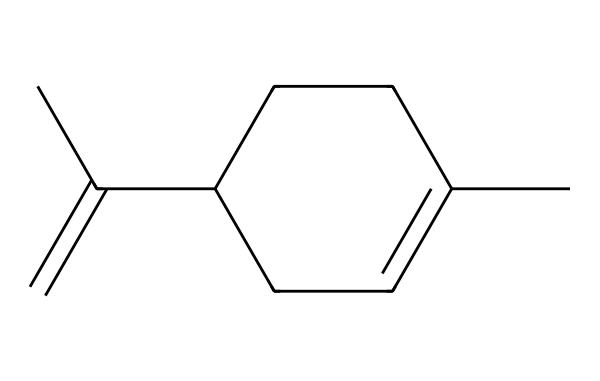What is the molecular formula of limonene? To determine the molecular formula, we can count the number of carbon (C) and hydrogen (H) atoms in the structure based on the SMILES representation. There are 10 carbon atoms and 16 hydrogen atoms present in the structure.
Answer: C10H16 How many rings are present in the structure? By analyzing the SMILES notation, we can observe the presence of a ring indicated by 'C1=...' and 'CC1' which shows that there is one ring in the structure.
Answer: 1 What type of bond connects the carbon atoms in the ring? The presence of '=' in the SMILES indicates a double bond between carbon atoms in the ring. This can be seen in the portion 'CC1=CCC', confirming the existence of double bonds in the cyclic structure.
Answer: double bond Is limonene an aromatic compound? Limonene does not contain a fully conjugated pi electron system nor a benzene-like ring that would classify it as aromatic. Even though it has a cyclic structure, it lacks the specific characteristics of aromaticity.
Answer: no What characteristic scent is limonene responsible for? Limonene is primarily recognized for emitting a citrus scent, which is attributed to the arrangement of its molecular structure, notably as it relates to its carbon framework and functional groups.
Answer: citrus scent Which is the major functional group in limonene? Analyzing the structure, limonene primarily features a double bond between carbon atoms, typical of alkenes rather than a distinct functional group like alcohol or ketone. This double bond can be identified as the main functional feature.
Answer: alkene 